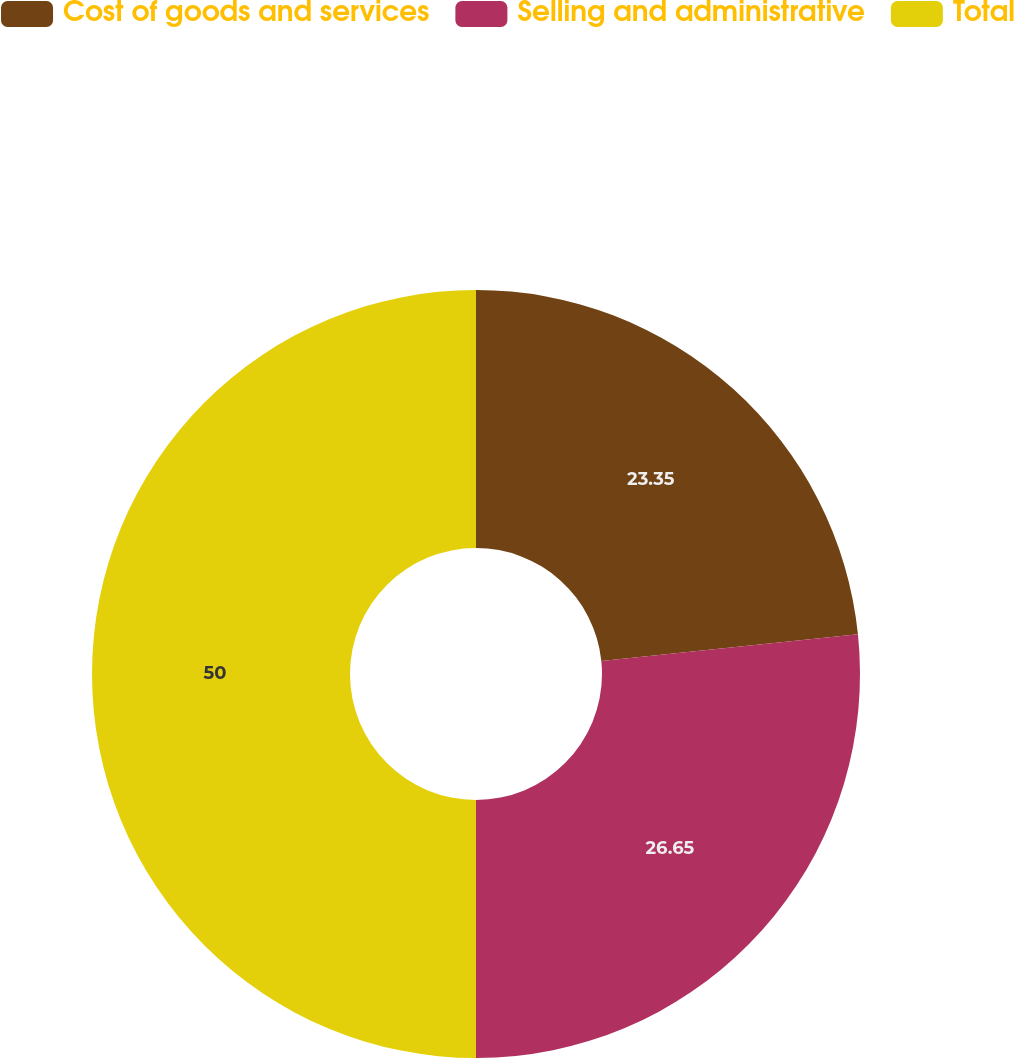<chart> <loc_0><loc_0><loc_500><loc_500><pie_chart><fcel>Cost of goods and services<fcel>Selling and administrative<fcel>Total<nl><fcel>23.35%<fcel>26.65%<fcel>50.0%<nl></chart> 